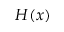Convert formula to latex. <formula><loc_0><loc_0><loc_500><loc_500>H ( x )</formula> 